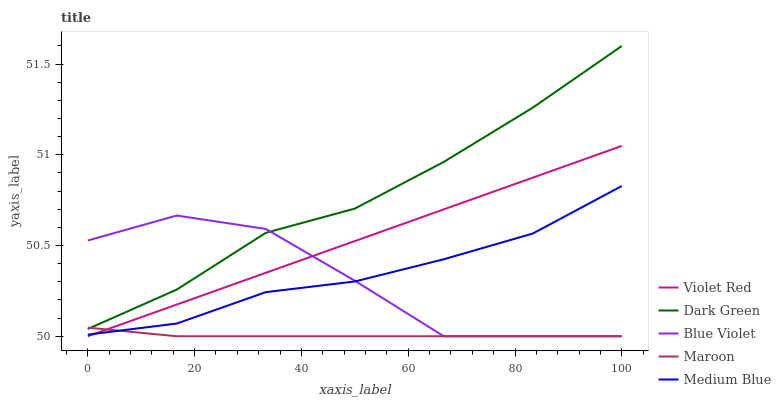Does Maroon have the minimum area under the curve?
Answer yes or no. Yes. Does Dark Green have the maximum area under the curve?
Answer yes or no. Yes. Does Medium Blue have the minimum area under the curve?
Answer yes or no. No. Does Medium Blue have the maximum area under the curve?
Answer yes or no. No. Is Violet Red the smoothest?
Answer yes or no. Yes. Is Blue Violet the roughest?
Answer yes or no. Yes. Is Medium Blue the smoothest?
Answer yes or no. No. Is Medium Blue the roughest?
Answer yes or no. No. Does Violet Red have the lowest value?
Answer yes or no. Yes. Does Medium Blue have the lowest value?
Answer yes or no. No. Does Dark Green have the highest value?
Answer yes or no. Yes. Does Medium Blue have the highest value?
Answer yes or no. No. Is Violet Red less than Dark Green?
Answer yes or no. Yes. Is Dark Green greater than Medium Blue?
Answer yes or no. Yes. Does Blue Violet intersect Medium Blue?
Answer yes or no. Yes. Is Blue Violet less than Medium Blue?
Answer yes or no. No. Is Blue Violet greater than Medium Blue?
Answer yes or no. No. Does Violet Red intersect Dark Green?
Answer yes or no. No. 